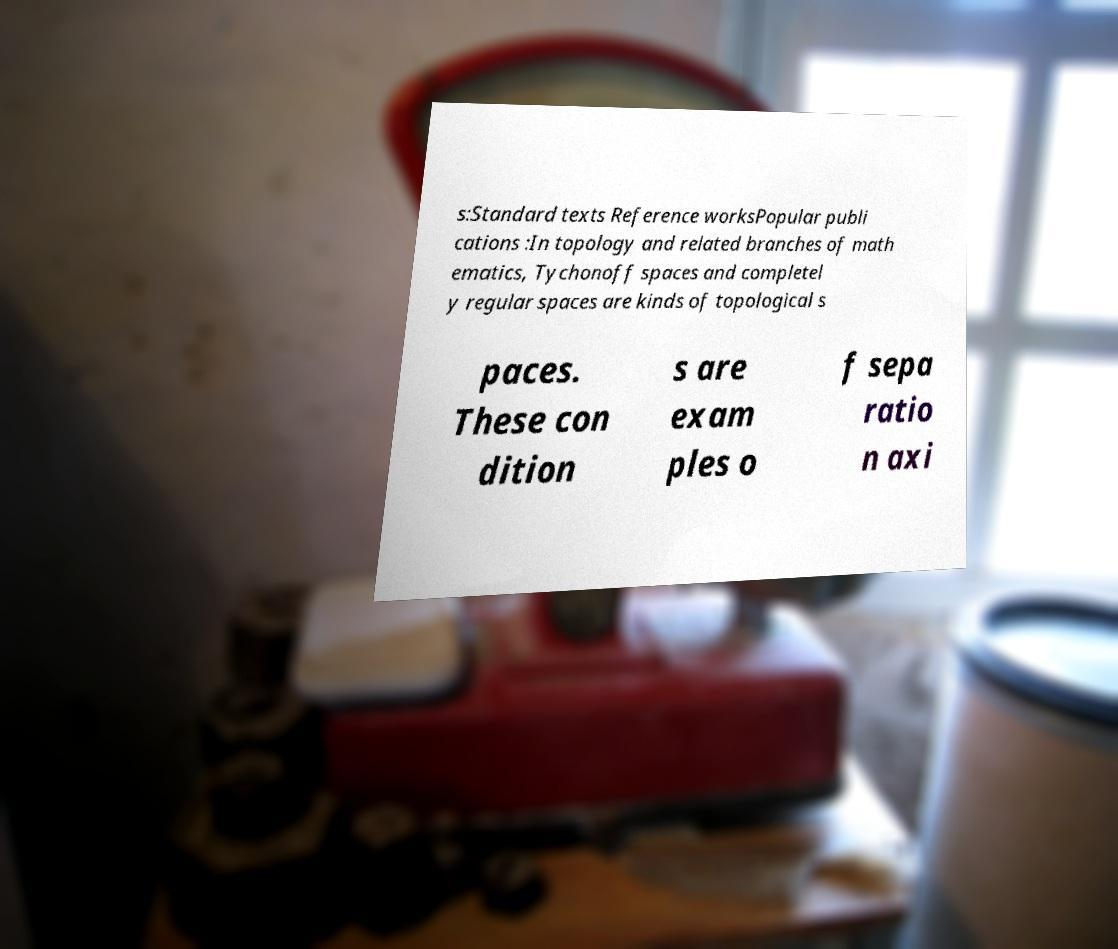Could you extract and type out the text from this image? s:Standard texts Reference worksPopular publi cations :In topology and related branches of math ematics, Tychonoff spaces and completel y regular spaces are kinds of topological s paces. These con dition s are exam ples o f sepa ratio n axi 